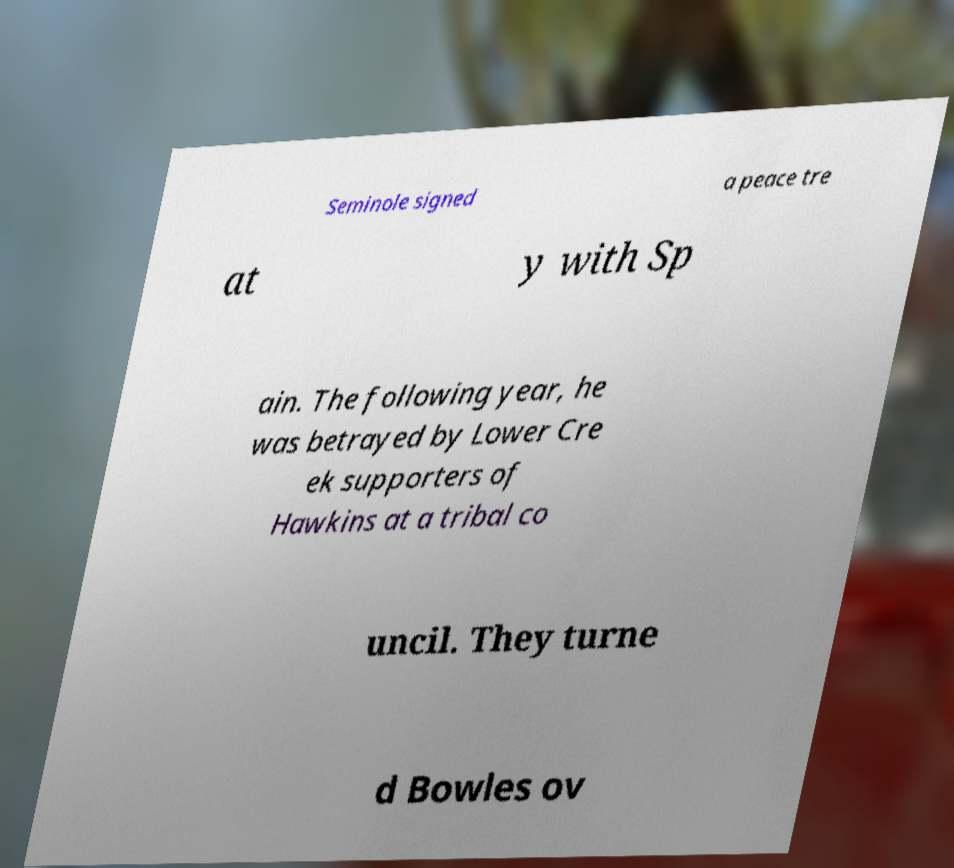There's text embedded in this image that I need extracted. Can you transcribe it verbatim? Seminole signed a peace tre at y with Sp ain. The following year, he was betrayed by Lower Cre ek supporters of Hawkins at a tribal co uncil. They turne d Bowles ov 